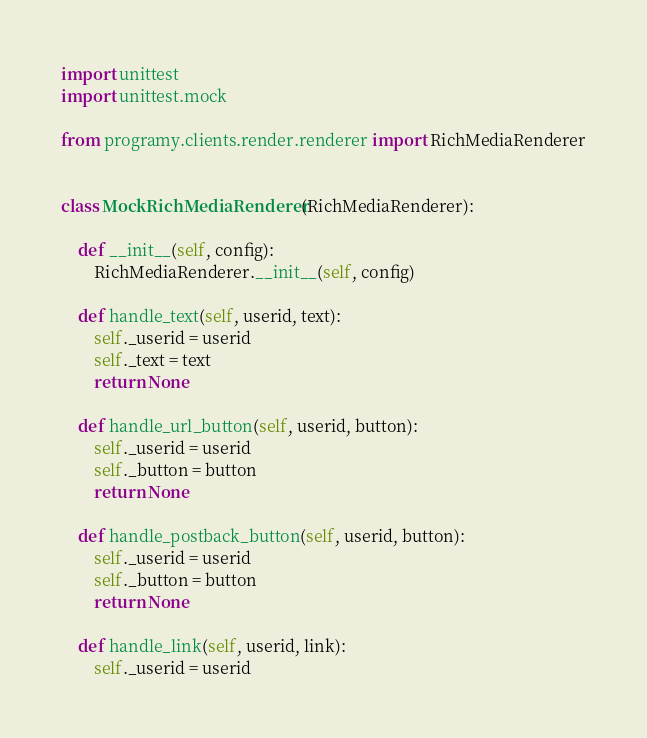<code> <loc_0><loc_0><loc_500><loc_500><_Python_>import unittest
import unittest.mock

from programy.clients.render.renderer import RichMediaRenderer


class MockRichMediaRenderer(RichMediaRenderer):

    def __init__(self, config):
        RichMediaRenderer.__init__(self, config)

    def handle_text(self, userid, text):
        self._userid = userid
        self._text = text
        return None

    def handle_url_button(self, userid, button):
        self._userid = userid
        self._button = button
        return None

    def handle_postback_button(self, userid, button):
        self._userid = userid
        self._button = button
        return None

    def handle_link(self, userid, link):
        self._userid = userid</code> 